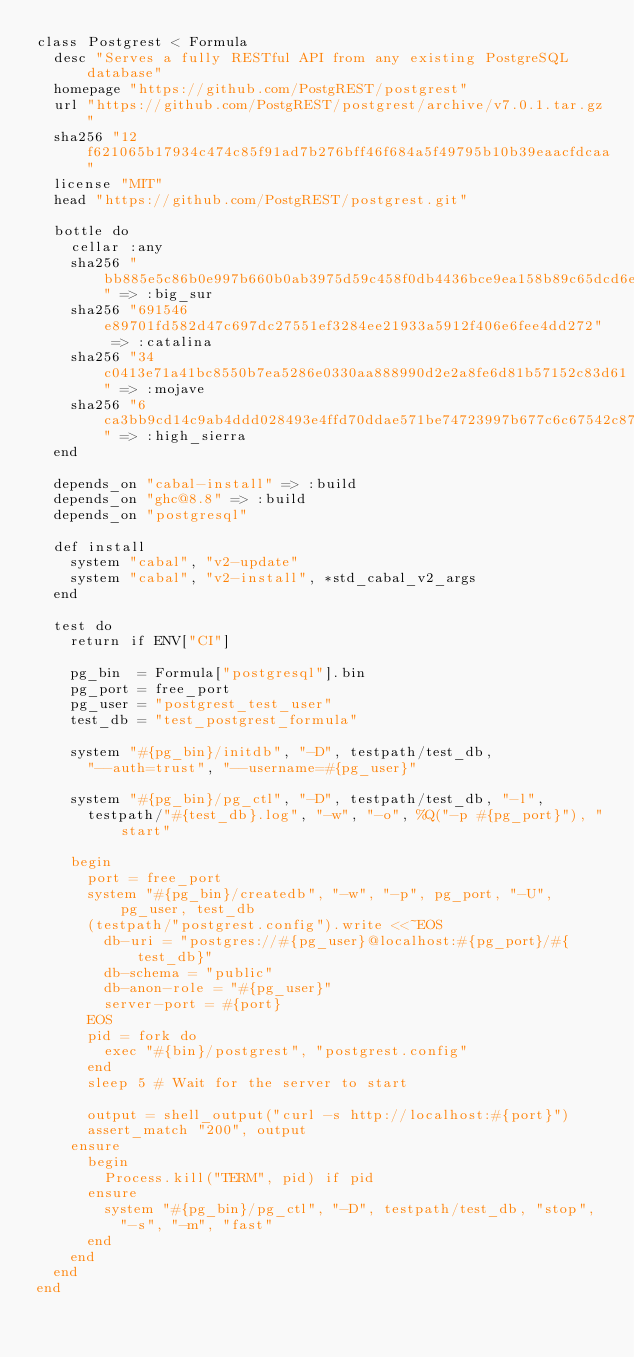Convert code to text. <code><loc_0><loc_0><loc_500><loc_500><_Ruby_>class Postgrest < Formula
  desc "Serves a fully RESTful API from any existing PostgreSQL database"
  homepage "https://github.com/PostgREST/postgrest"
  url "https://github.com/PostgREST/postgrest/archive/v7.0.1.tar.gz"
  sha256 "12f621065b17934c474c85f91ad7b276bff46f684a5f49795b10b39eaacfdcaa"
  license "MIT"
  head "https://github.com/PostgREST/postgrest.git"

  bottle do
    cellar :any
    sha256 "bb885e5c86b0e997b660b0ab3975d59c458f0db4436bce9ea158b89c65dcd6e2" => :big_sur
    sha256 "691546e89701fd582d47c697dc27551ef3284ee21933a5912f406e6fee4dd272" => :catalina
    sha256 "34c0413e71a41bc8550b7ea5286e0330aa888990d2e2a8fe6d81b57152c83d61" => :mojave
    sha256 "6ca3bb9cd14c9ab4ddd028493e4ffd70ddae571be74723997b677c6c67542c87" => :high_sierra
  end

  depends_on "cabal-install" => :build
  depends_on "ghc@8.8" => :build
  depends_on "postgresql"

  def install
    system "cabal", "v2-update"
    system "cabal", "v2-install", *std_cabal_v2_args
  end

  test do
    return if ENV["CI"]

    pg_bin  = Formula["postgresql"].bin
    pg_port = free_port
    pg_user = "postgrest_test_user"
    test_db = "test_postgrest_formula"

    system "#{pg_bin}/initdb", "-D", testpath/test_db,
      "--auth=trust", "--username=#{pg_user}"

    system "#{pg_bin}/pg_ctl", "-D", testpath/test_db, "-l",
      testpath/"#{test_db}.log", "-w", "-o", %Q("-p #{pg_port}"), "start"

    begin
      port = free_port
      system "#{pg_bin}/createdb", "-w", "-p", pg_port, "-U", pg_user, test_db
      (testpath/"postgrest.config").write <<~EOS
        db-uri = "postgres://#{pg_user}@localhost:#{pg_port}/#{test_db}"
        db-schema = "public"
        db-anon-role = "#{pg_user}"
        server-port = #{port}
      EOS
      pid = fork do
        exec "#{bin}/postgrest", "postgrest.config"
      end
      sleep 5 # Wait for the server to start

      output = shell_output("curl -s http://localhost:#{port}")
      assert_match "200", output
    ensure
      begin
        Process.kill("TERM", pid) if pid
      ensure
        system "#{pg_bin}/pg_ctl", "-D", testpath/test_db, "stop",
          "-s", "-m", "fast"
      end
    end
  end
end
</code> 